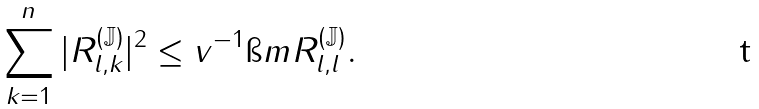Convert formula to latex. <formula><loc_0><loc_0><loc_500><loc_500>\sum _ { k = 1 } ^ { n } | R ^ { ( \mathbb { J } ) } _ { l , k } | ^ { 2 } \leq v ^ { - 1 } \i m R ^ { ( \mathbb { J } ) } _ { l , l } .</formula> 